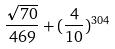Convert formula to latex. <formula><loc_0><loc_0><loc_500><loc_500>\frac { \sqrt { 7 0 } } { 4 6 9 } + ( \frac { 4 } { 1 0 } ) ^ { 3 0 4 }</formula> 